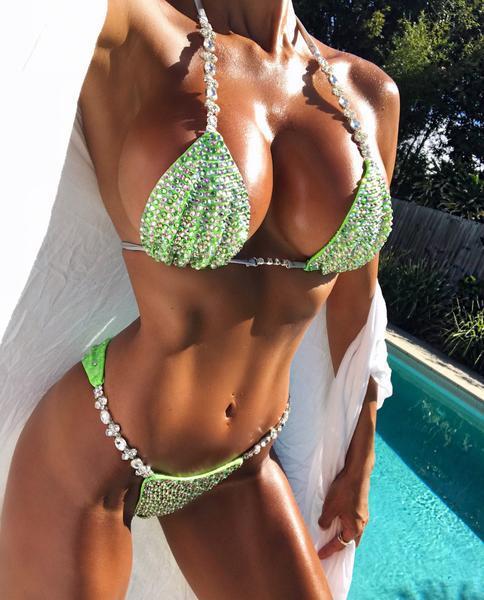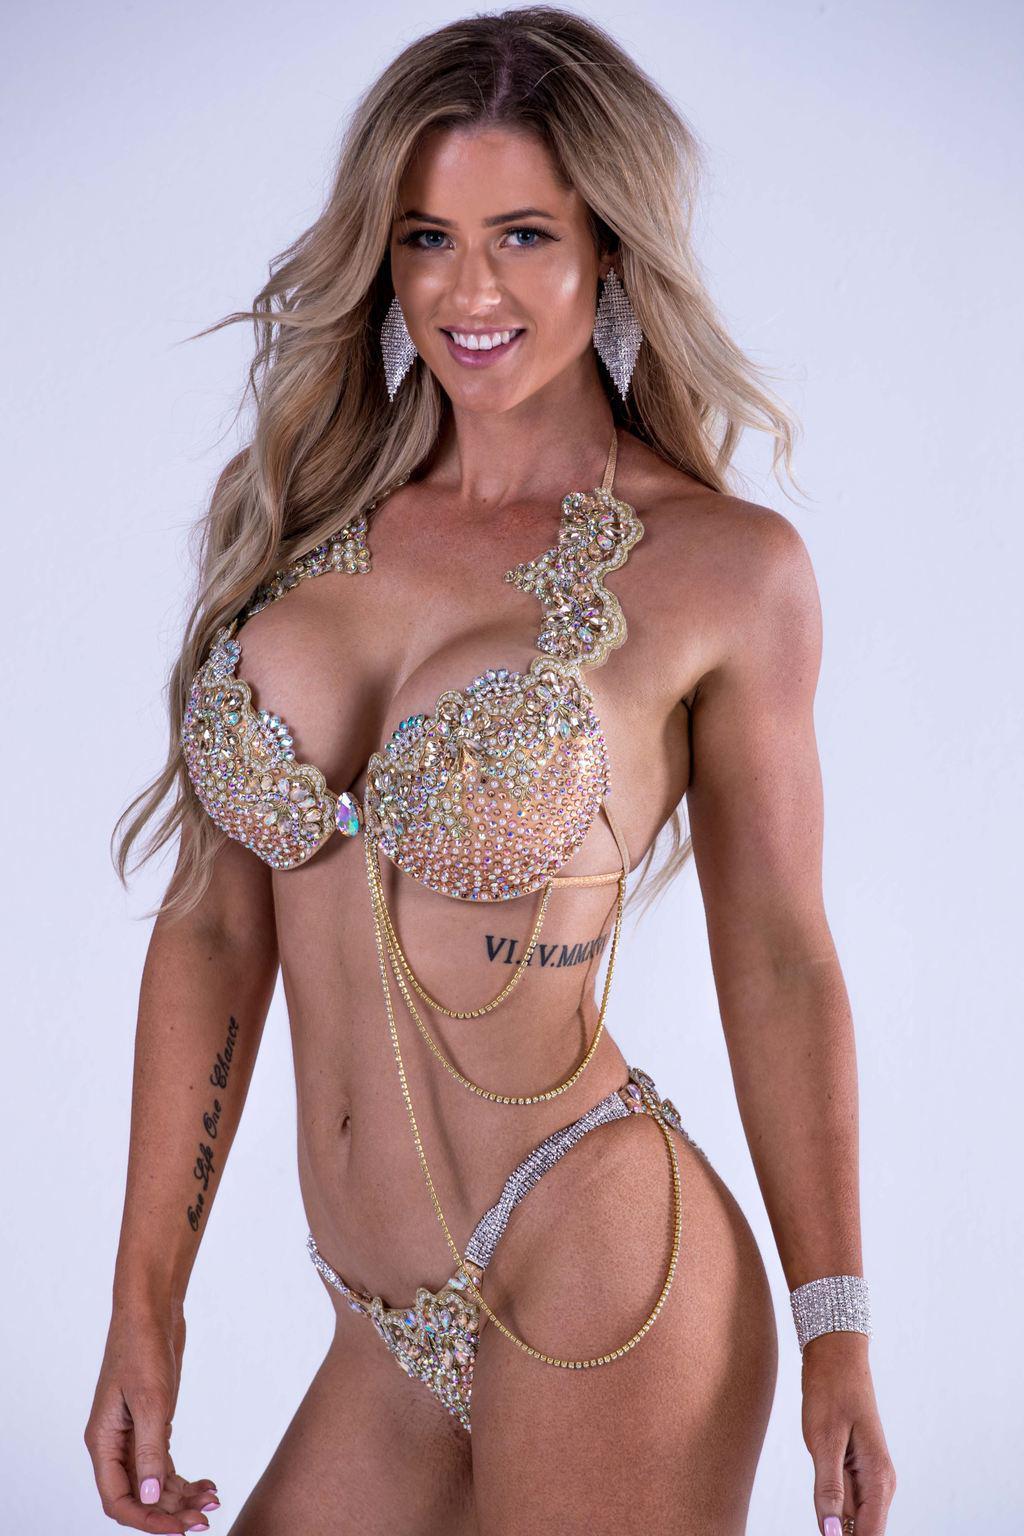The first image is the image on the left, the second image is the image on the right. Assess this claim about the two images: "The left and right image contains the same number of bikinis with one being gold.". Correct or not? Answer yes or no. No. The first image is the image on the left, the second image is the image on the right. Analyze the images presented: Is the assertion "An image shows a woman wearing a shiny gold bikini and posing with her arm on her hip." valid? Answer yes or no. No. 